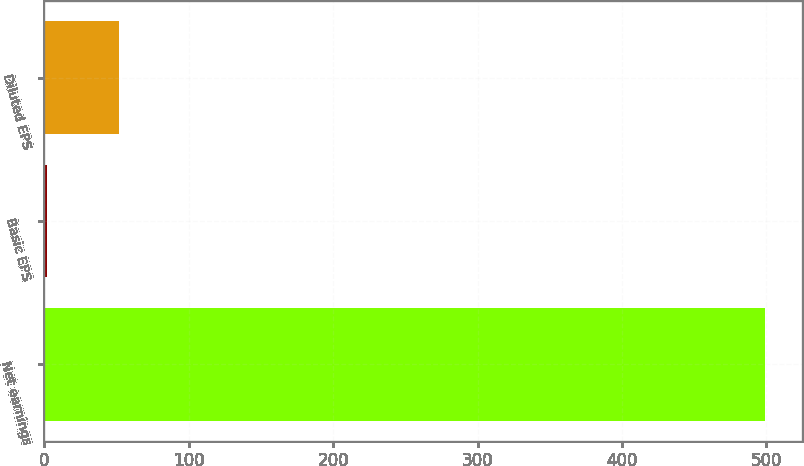Convert chart. <chart><loc_0><loc_0><loc_500><loc_500><bar_chart><fcel>Net earnings<fcel>Basic EPS<fcel>Diluted EPS<nl><fcel>499.4<fcel>1.73<fcel>51.5<nl></chart> 